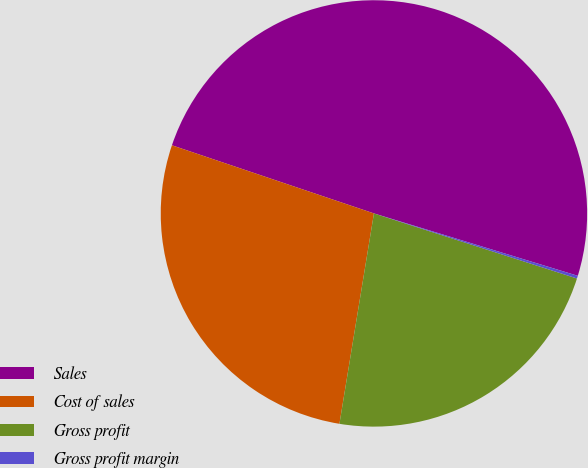Convert chart. <chart><loc_0><loc_0><loc_500><loc_500><pie_chart><fcel>Sales<fcel>Cost of sales<fcel>Gross profit<fcel>Gross profit margin<nl><fcel>49.55%<fcel>27.59%<fcel>22.65%<fcel>0.21%<nl></chart> 